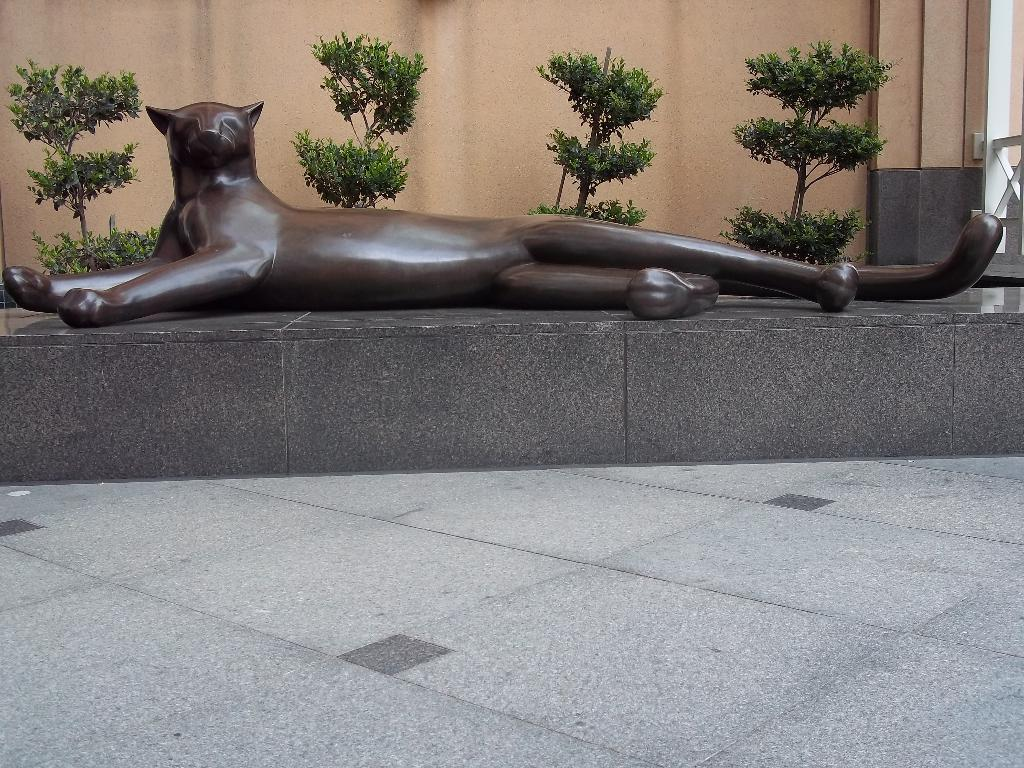What is the main subject of the image? There is a sculpture of a black jaguar in the image. What is the sculpture sitting on? The sculpture is sitting on a stone. What type of vegetation can be seen in the image? There are small trees with branches and leaves in the image. What architectural feature is present in the image? There is a wall in the image. Where is the shelf located in the image? There is no shelf present in the image. Can you tell me what the judge is wearing in the image? There is no judge present in the image. 